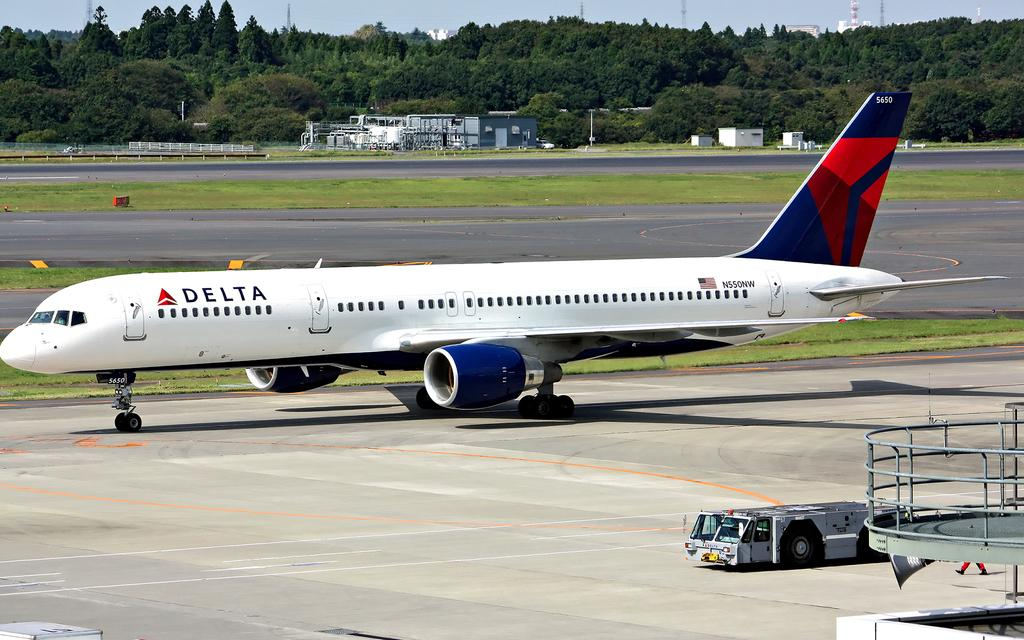<image>
Write a terse but informative summary of the picture. Delta airplane is not on the air but on the ground 